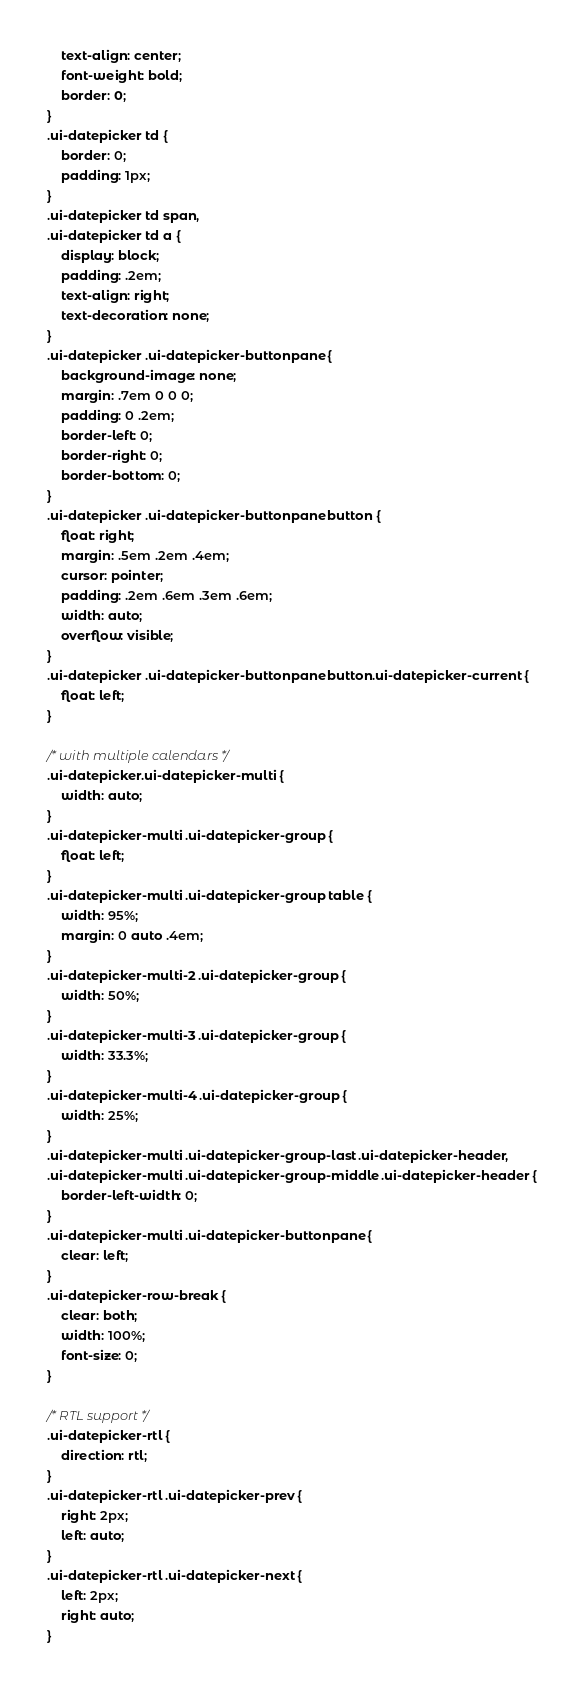<code> <loc_0><loc_0><loc_500><loc_500><_CSS_>	text-align: center;
	font-weight: bold;
	border: 0;
}
.ui-datepicker td {
	border: 0;
	padding: 1px;
}
.ui-datepicker td span,
.ui-datepicker td a {
	display: block;
	padding: .2em;
	text-align: right;
	text-decoration: none;
}
.ui-datepicker .ui-datepicker-buttonpane {
	background-image: none;
	margin: .7em 0 0 0;
	padding: 0 .2em;
	border-left: 0;
	border-right: 0;
	border-bottom: 0;
}
.ui-datepicker .ui-datepicker-buttonpane button {
	float: right;
	margin: .5em .2em .4em;
	cursor: pointer;
	padding: .2em .6em .3em .6em;
	width: auto;
	overflow: visible;
}
.ui-datepicker .ui-datepicker-buttonpane button.ui-datepicker-current {
	float: left;
}

/* with multiple calendars */
.ui-datepicker.ui-datepicker-multi {
	width: auto;
}
.ui-datepicker-multi .ui-datepicker-group {
	float: left;
}
.ui-datepicker-multi .ui-datepicker-group table {
	width: 95%;
	margin: 0 auto .4em;
}
.ui-datepicker-multi-2 .ui-datepicker-group {
	width: 50%;
}
.ui-datepicker-multi-3 .ui-datepicker-group {
	width: 33.3%;
}
.ui-datepicker-multi-4 .ui-datepicker-group {
	width: 25%;
}
.ui-datepicker-multi .ui-datepicker-group-last .ui-datepicker-header,
.ui-datepicker-multi .ui-datepicker-group-middle .ui-datepicker-header {
	border-left-width: 0;
}
.ui-datepicker-multi .ui-datepicker-buttonpane {
	clear: left;
}
.ui-datepicker-row-break {
	clear: both;
	width: 100%;
	font-size: 0;
}

/* RTL support */
.ui-datepicker-rtl {
	direction: rtl;
}
.ui-datepicker-rtl .ui-datepicker-prev {
	right: 2px;
	left: auto;
}
.ui-datepicker-rtl .ui-datepicker-next {
	left: 2px;
	right: auto;
}</code> 